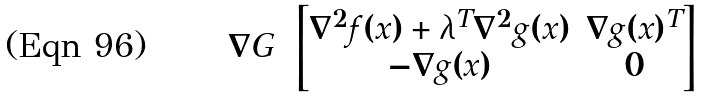Convert formula to latex. <formula><loc_0><loc_0><loc_500><loc_500>\nabla G = \begin{bmatrix} \nabla ^ { 2 } f ( x ) + \lambda ^ { T } \nabla ^ { 2 } g ( x ) & \nabla g ( x ) ^ { T } \\ - \nabla g ( x ) & 0 \end{bmatrix}</formula> 